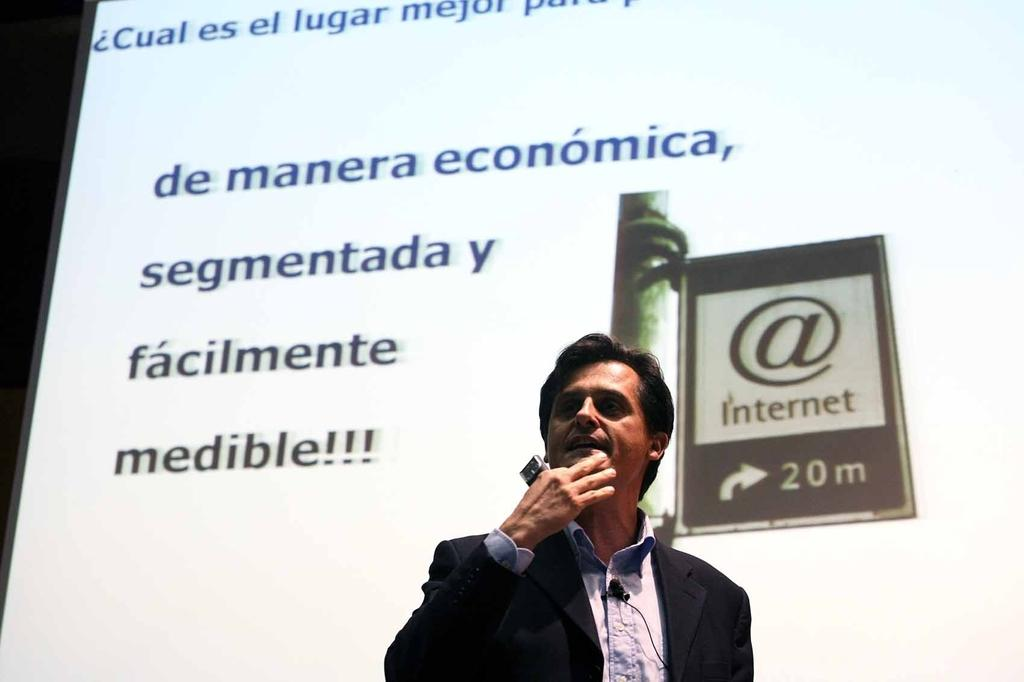Who is present in the image? There is a person in the image. What is the person wearing? The person is wearing a suit. Where is the person standing in relation to the projector screen? The person is standing in front of a projector screen. What can be seen on the projector screen? There is something displayed on the projector screen. How many girls are present in the image? There is no mention of girls in the provided facts, so we cannot determine their presence in the image. 